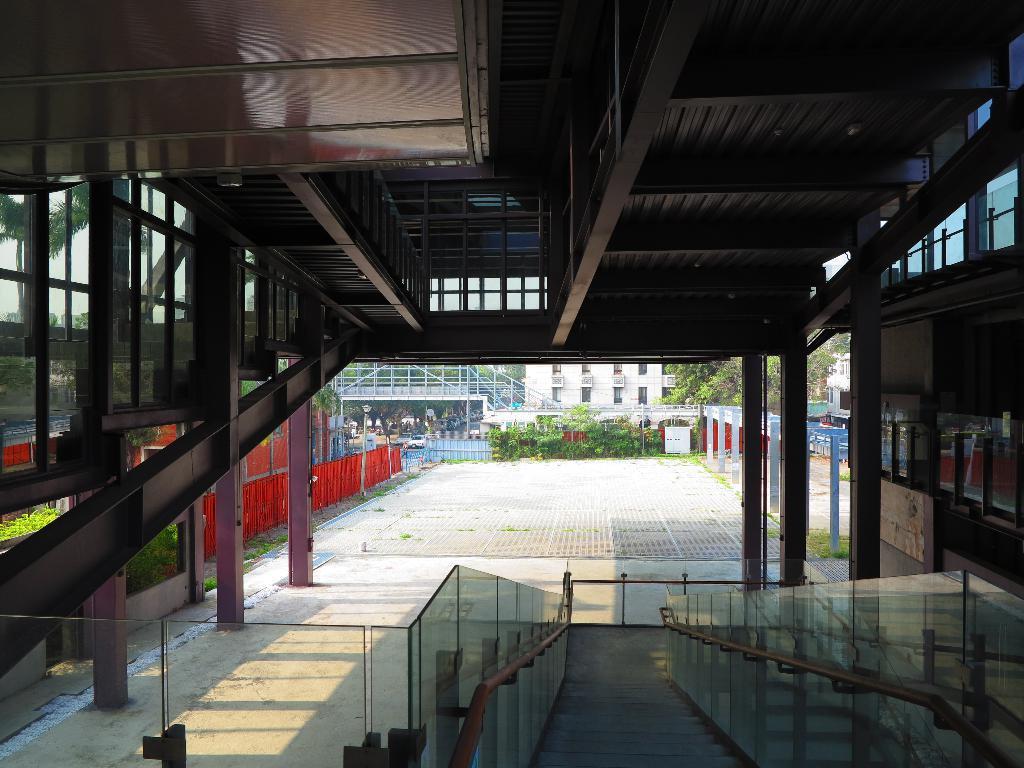Please provide a concise description of this image. In this picture I can observe a building. In the bottom of the picture there is a glass railing. In the background there are plants and trees. 